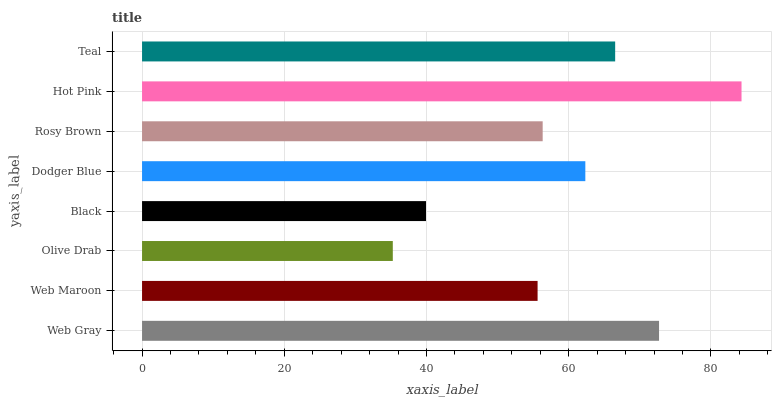Is Olive Drab the minimum?
Answer yes or no. Yes. Is Hot Pink the maximum?
Answer yes or no. Yes. Is Web Maroon the minimum?
Answer yes or no. No. Is Web Maroon the maximum?
Answer yes or no. No. Is Web Gray greater than Web Maroon?
Answer yes or no. Yes. Is Web Maroon less than Web Gray?
Answer yes or no. Yes. Is Web Maroon greater than Web Gray?
Answer yes or no. No. Is Web Gray less than Web Maroon?
Answer yes or no. No. Is Dodger Blue the high median?
Answer yes or no. Yes. Is Rosy Brown the low median?
Answer yes or no. Yes. Is Teal the high median?
Answer yes or no. No. Is Dodger Blue the low median?
Answer yes or no. No. 